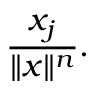<formula> <loc_0><loc_0><loc_500><loc_500>{ \frac { x _ { j } } { \| x \| ^ { n } } } .</formula> 